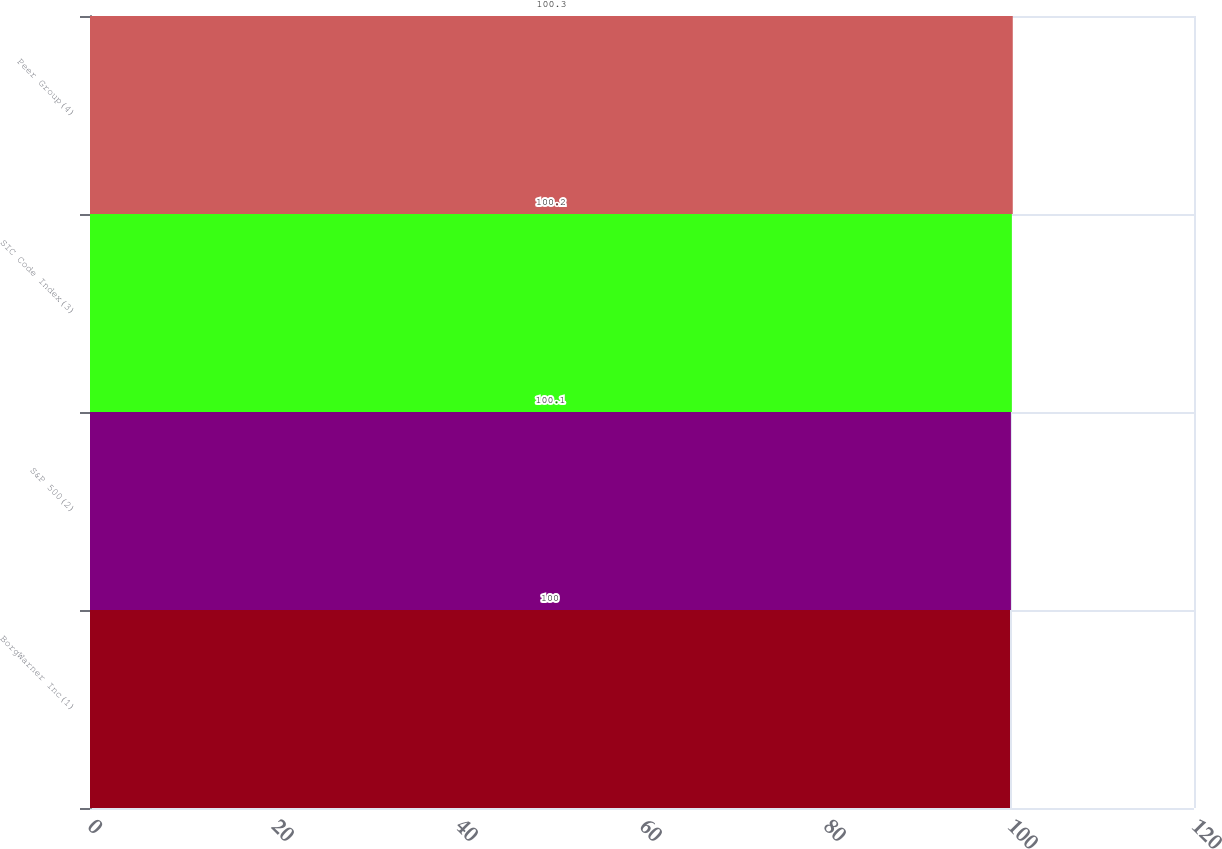Convert chart. <chart><loc_0><loc_0><loc_500><loc_500><bar_chart><fcel>BorgWarner Inc(1)<fcel>S&P 500(2)<fcel>SIC Code Index(3)<fcel>Peer Group(4)<nl><fcel>100<fcel>100.1<fcel>100.2<fcel>100.3<nl></chart> 